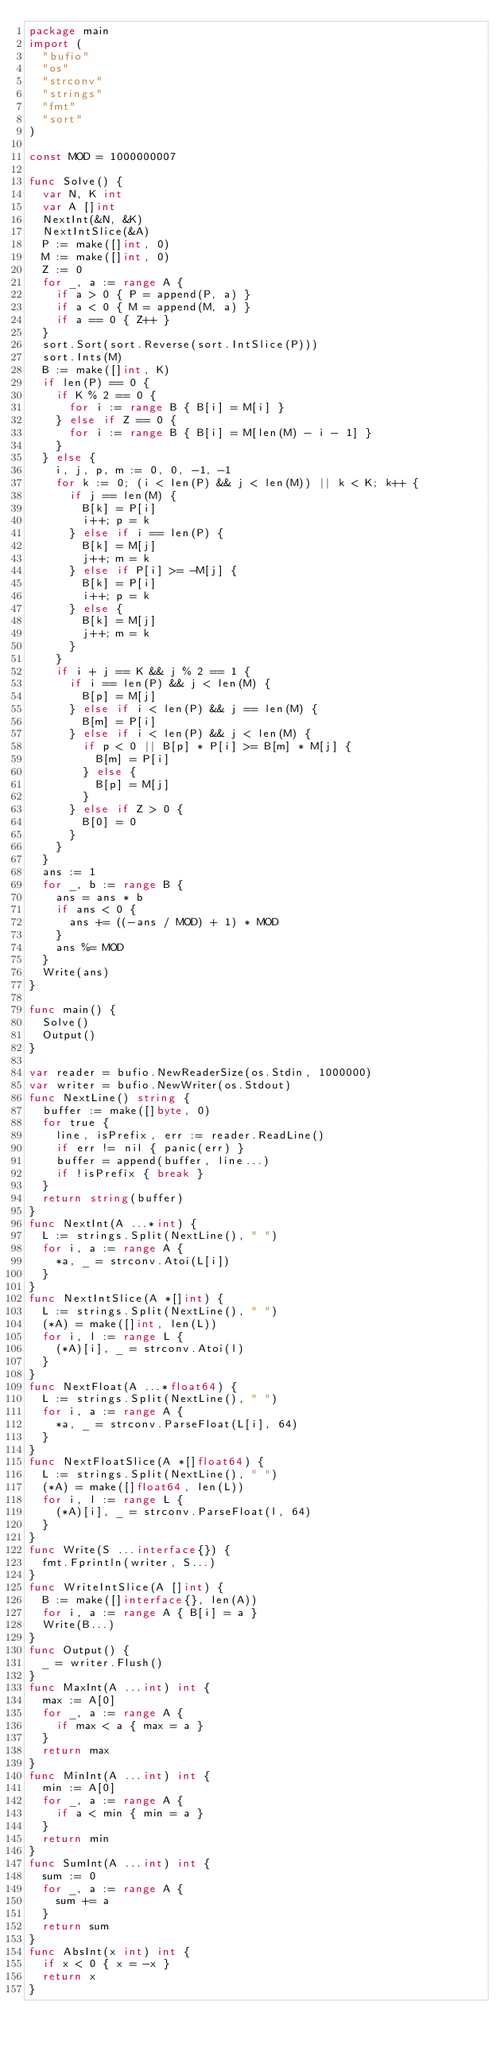Convert code to text. <code><loc_0><loc_0><loc_500><loc_500><_Go_>package main
import (
  "bufio"
  "os"
  "strconv"
  "strings"
  "fmt"
  "sort"
)

const MOD = 1000000007

func Solve() {
  var N, K int
  var A []int
  NextInt(&N, &K)
  NextIntSlice(&A)
  P := make([]int, 0)
  M := make([]int, 0)
  Z := 0
  for _, a := range A {
    if a > 0 { P = append(P, a) }
    if a < 0 { M = append(M, a) }
    if a == 0 { Z++ }
  }
  sort.Sort(sort.Reverse(sort.IntSlice(P)))
  sort.Ints(M)
  B := make([]int, K)
  if len(P) == 0 {
    if K % 2 == 0 {
      for i := range B { B[i] = M[i] }
    } else if Z == 0 {
      for i := range B { B[i] = M[len(M) - i - 1] }
    }
  } else {
    i, j, p, m := 0, 0, -1, -1
    for k := 0; (i < len(P) && j < len(M)) || k < K; k++ {
      if j == len(M) {
        B[k] = P[i]
        i++; p = k
      } else if i == len(P) {
        B[k] = M[j]
        j++; m = k
      } else if P[i] >= -M[j] {
        B[k] = P[i]
        i++; p = k
      } else {
        B[k] = M[j]
        j++; m = k
      }
    }
    if i + j == K && j % 2 == 1 {
      if i == len(P) && j < len(M) {
        B[p] = M[j]
      } else if i < len(P) && j == len(M) {
        B[m] = P[i]
      } else if i < len(P) && j < len(M) {
        if p < 0 || B[p] * P[i] >= B[m] * M[j] {
          B[m] = P[i]
        } else {
          B[p] = M[j]
        }
      } else if Z > 0 {
        B[0] = 0
      }
    }
  }
  ans := 1
  for _, b := range B {
    ans = ans * b
    if ans < 0 {
      ans += ((-ans / MOD) + 1) * MOD
    }
    ans %= MOD
  }
  Write(ans)
}

func main() {
  Solve()
  Output()
}

var reader = bufio.NewReaderSize(os.Stdin, 1000000)
var writer = bufio.NewWriter(os.Stdout)
func NextLine() string {
  buffer := make([]byte, 0)
  for true {
    line, isPrefix, err := reader.ReadLine()
    if err != nil { panic(err) }
    buffer = append(buffer, line...)
    if !isPrefix { break }
  }
  return string(buffer)
}
func NextInt(A ...*int) {
  L := strings.Split(NextLine(), " ")
  for i, a := range A {
    *a, _ = strconv.Atoi(L[i])
  }
}
func NextIntSlice(A *[]int) {
  L := strings.Split(NextLine(), " ")
  (*A) = make([]int, len(L))
  for i, l := range L {
    (*A)[i], _ = strconv.Atoi(l)
  }
}
func NextFloat(A ...*float64) {
  L := strings.Split(NextLine(), " ")
  for i, a := range A {
    *a, _ = strconv.ParseFloat(L[i], 64)
  }
}
func NextFloatSlice(A *[]float64) {
  L := strings.Split(NextLine(), " ")
  (*A) = make([]float64, len(L))
  for i, l := range L {
    (*A)[i], _ = strconv.ParseFloat(l, 64)
  }
}
func Write(S ...interface{}) {
  fmt.Fprintln(writer, S...)
}
func WriteIntSlice(A []int) {
  B := make([]interface{}, len(A))
  for i, a := range A { B[i] = a }
  Write(B...)
}
func Output() {
  _ = writer.Flush()
}
func MaxInt(A ...int) int {
  max := A[0]
  for _, a := range A {
    if max < a { max = a }
  }
  return max
}
func MinInt(A ...int) int {
  min := A[0]
  for _, a := range A {
    if a < min { min = a }
  }
  return min
}
func SumInt(A ...int) int {
  sum := 0
  for _, a := range A {
    sum += a
  }
  return sum
}
func AbsInt(x int) int {
  if x < 0 { x = -x }
  return x
}</code> 